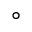Convert formula to latex. <formula><loc_0><loc_0><loc_500><loc_500>^ { \circ }</formula> 